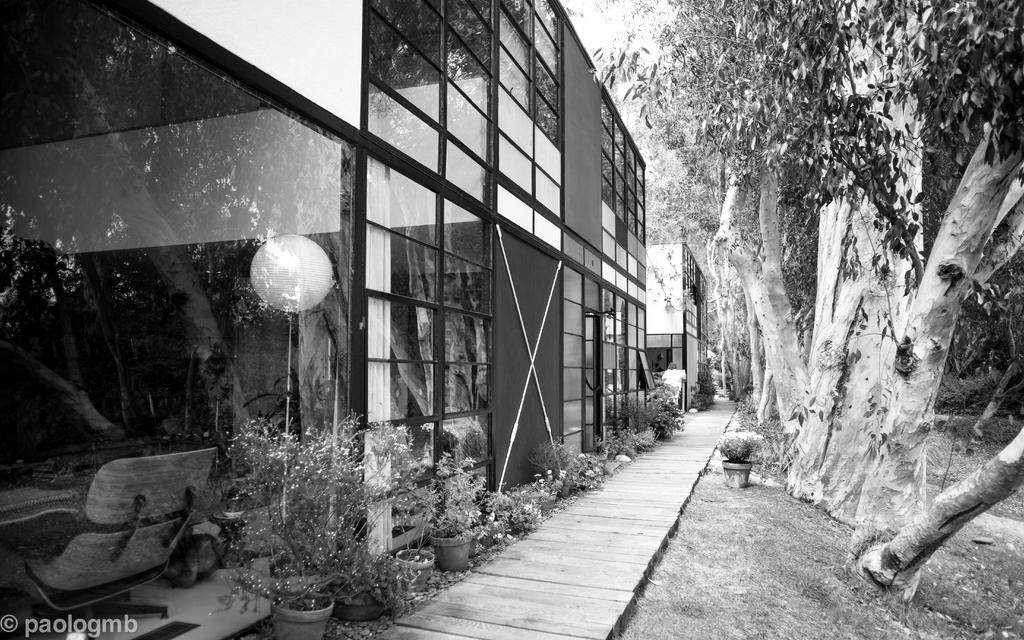What type of structure is visible in the image? There is a building in the image. What can be seen at the bottom of the image? There are plants at the bottom of the image. What type of vegetation is present to the right of the image? There are trees to the right of the image. What is the main feature in the middle of the image? There is a path in the middle of the image. What type of unit is being used to measure the height of the trees in the image? There is no unit present in the image, and the height of the trees is not being measured. Is there a veil covering the building in the image? No, there is no veil present in the image. 